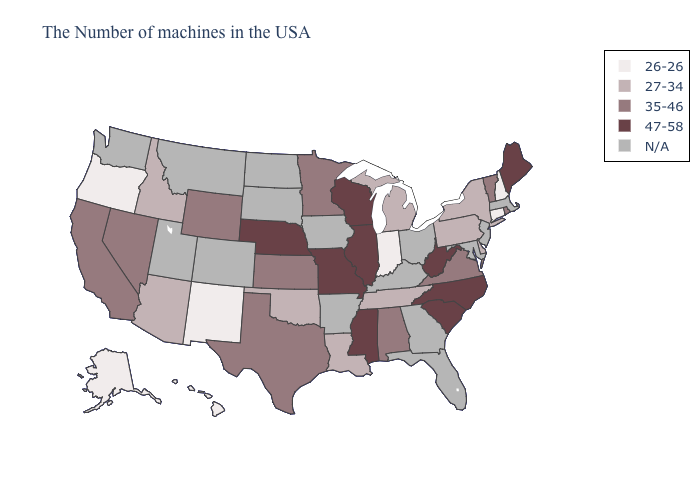What is the value of Kentucky?
Be succinct. N/A. Which states have the lowest value in the West?
Quick response, please. New Mexico, Oregon, Alaska, Hawaii. Name the states that have a value in the range N/A?
Keep it brief. Massachusetts, New Jersey, Maryland, Ohio, Florida, Georgia, Kentucky, Arkansas, Iowa, South Dakota, North Dakota, Colorado, Utah, Montana, Washington. Among the states that border Iowa , does Minnesota have the lowest value?
Be succinct. Yes. Which states have the lowest value in the USA?
Answer briefly. New Hampshire, Connecticut, Indiana, New Mexico, Oregon, Alaska, Hawaii. Which states have the highest value in the USA?
Give a very brief answer. Maine, North Carolina, South Carolina, West Virginia, Wisconsin, Illinois, Mississippi, Missouri, Nebraska. Does Kansas have the lowest value in the MidWest?
Answer briefly. No. What is the value of Alaska?
Short answer required. 26-26. Does Nevada have the lowest value in the West?
Quick response, please. No. Which states have the highest value in the USA?
Quick response, please. Maine, North Carolina, South Carolina, West Virginia, Wisconsin, Illinois, Mississippi, Missouri, Nebraska. Among the states that border Kentucky , does Illinois have the highest value?
Short answer required. Yes. Which states hav the highest value in the Northeast?
Quick response, please. Maine. Which states have the lowest value in the South?
Quick response, please. Delaware, Tennessee, Louisiana, Oklahoma. What is the value of Alaska?
Concise answer only. 26-26. 